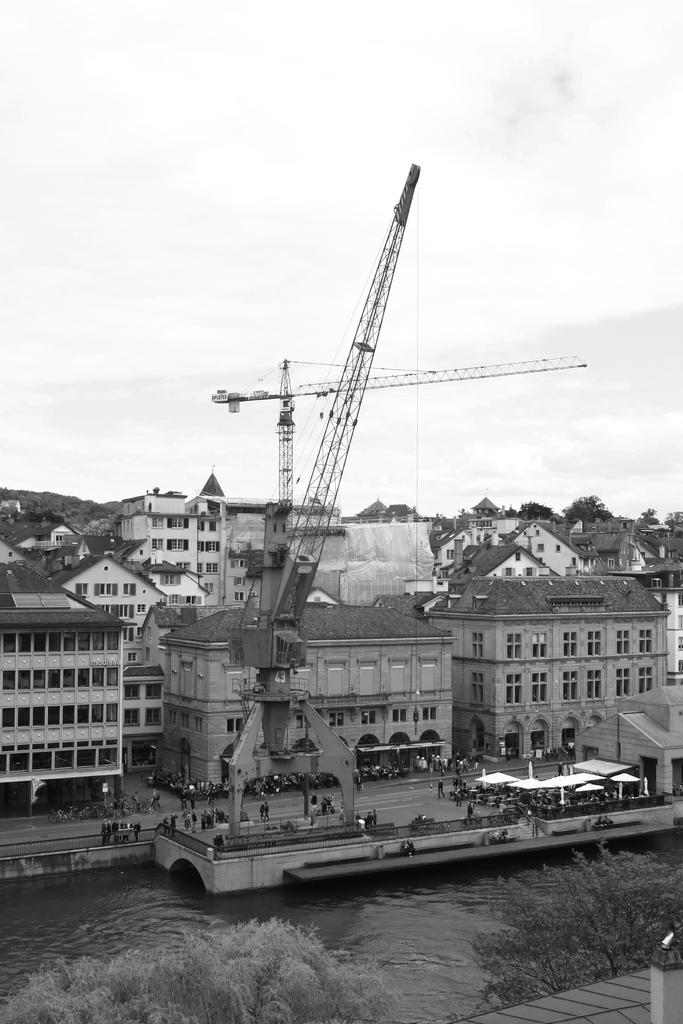What type of vehicle is present in the image? There is a mobile crane in the image. What structures can be seen in the middle of the image? There are buildings in the middle of the image. What natural elements are in the foreground of the image? There are two trees and a river flowing in the foreground of the image. What type of suit is the river wearing in the image? The river is not wearing a suit, as it is a natural element and not a person or object that can wear clothing. 